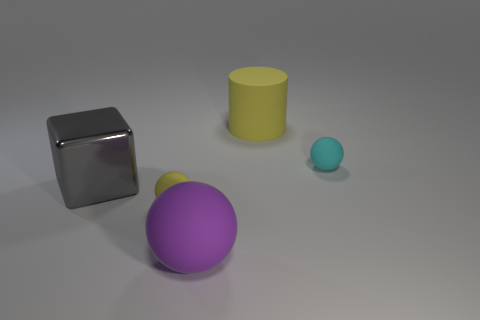What materials do the objects in the image appear to be made of? The objects in the image seem to be made of different materials. The cube appears to have a reflective metallic surface, the sphere looks like it might be made of a matte rubber material, the cylinder could be plastic given its matte finish, and the small ball seems to have a smoother, possibly painted surface. 